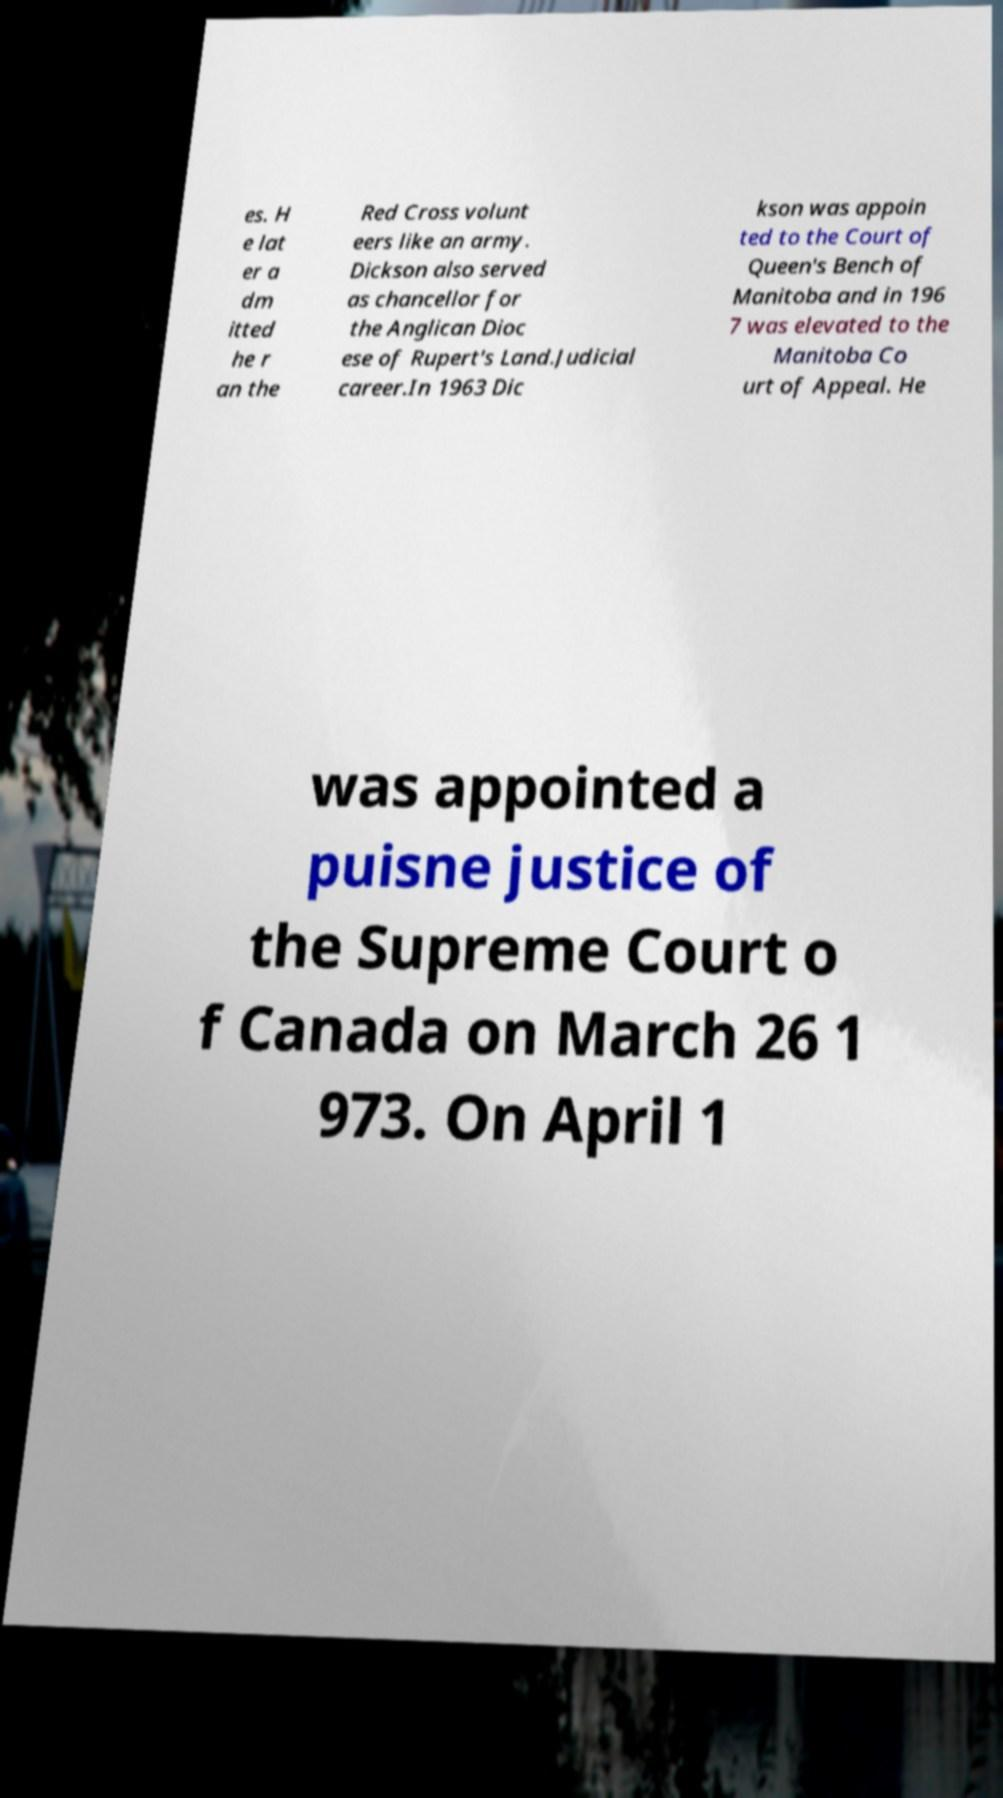Could you extract and type out the text from this image? es. H e lat er a dm itted he r an the Red Cross volunt eers like an army. Dickson also served as chancellor for the Anglican Dioc ese of Rupert's Land.Judicial career.In 1963 Dic kson was appoin ted to the Court of Queen's Bench of Manitoba and in 196 7 was elevated to the Manitoba Co urt of Appeal. He was appointed a puisne justice of the Supreme Court o f Canada on March 26 1 973. On April 1 